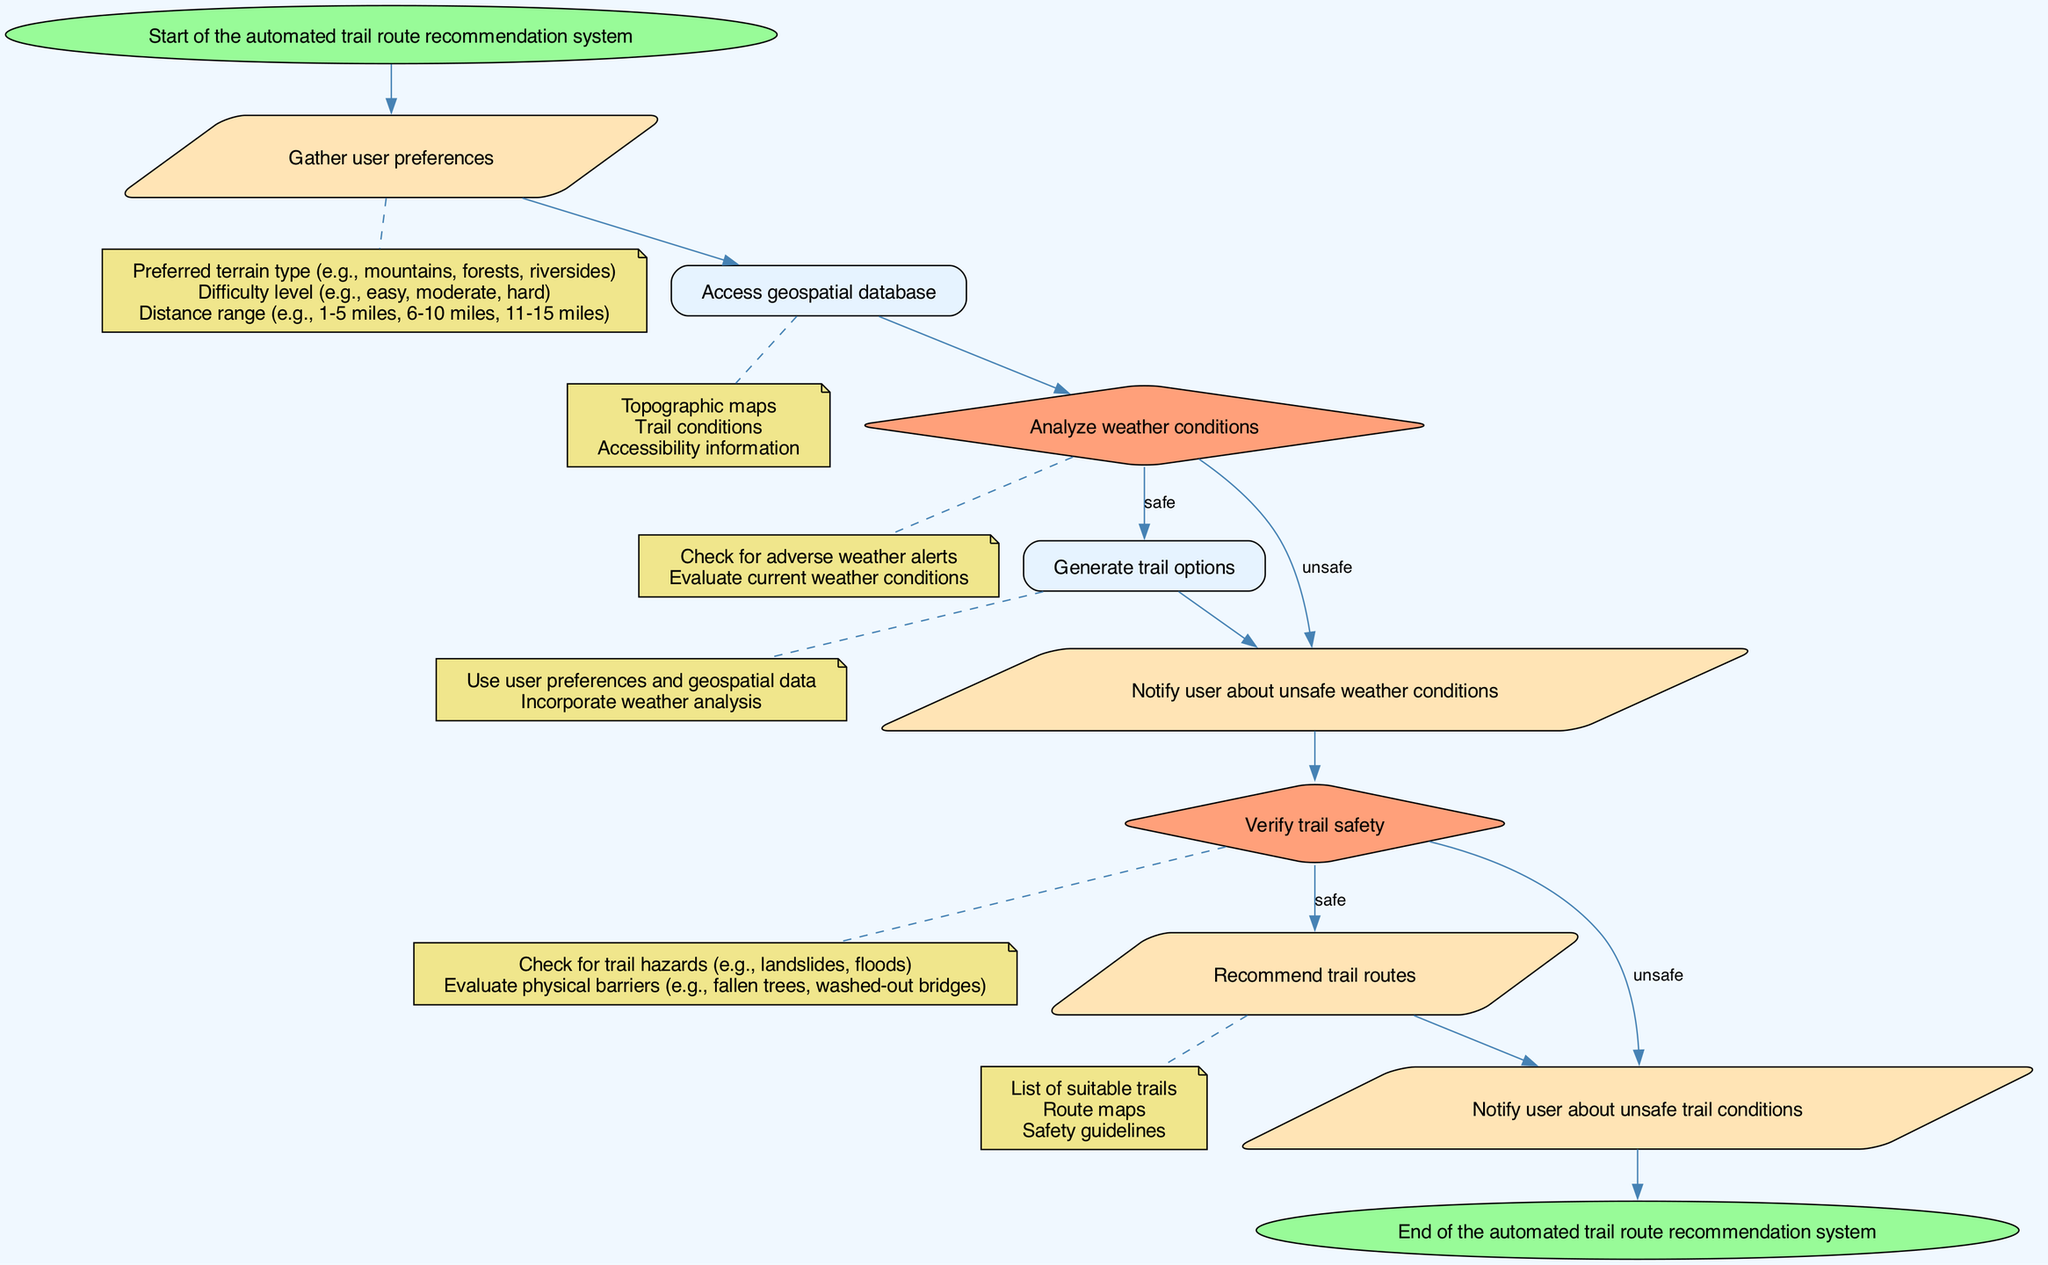What is the first node in the diagram? The diagram starts with the "Start" node, which marks the beginning of the automated trail route recommendation system. This is visually the first element in the flowchart labeled as "Start."
Answer: Start How many decision nodes are present in the diagram? The diagram contains two decision nodes: one to analyze weather conditions and the other to verify trail safety. These nodes are identified by their diamond shape in the flowchart.
Answer: 2 What type of information is gathered in the input node? The input node gathers user preferences, which include preferred terrain type, difficulty level, and distance range. This detail is presented under the input node in the flowchart.
Answer: User preferences What is the final output of the system if the trail is safe? When the trail is deemed safe, the system outputs a recommendation that includes a list of suitable trails, route maps, and safety guidelines, which follows the process of verifying trail safety.
Answer: Recommend trail routes What happens if the weather conditions are unsafe? If the weather conditions are unsafe, the system outputs a notification to the user about unsafe weather conditions. This clearly follows from the decision node evaluating weather safety in the flowchart.
Answer: Notify user about unsafe weather conditions How many edges connect the decision nodes to their respective outcomes? Each decision node has two edges connecting to their respective outcomes: one for a safe condition and one for an unsafe condition. Since there are two decision nodes, this results in a total of four edges.
Answer: 4 What is the last node in the flowchart? The last node in the flowchart is the "End" node, which signifies the completion of the automated trail route recommendation system. This is visually concluded in the flowchart.
Answer: End If a user prefers mountainous terrain and easy difficulty, which process follows after gathering preferences? After gathering the user preferences, the next process involves accessing the geospatial database, which is essential for generating relevant trail options based on the gathered data.
Answer: Access geospatial database What does the decision node evaluating trail safety check for? The decision node evaluating trail safety checks for trail hazards such as landslides and floods, as well as physical barriers like fallen trees. This detail is specified in the flowchart.
Answer: Trail hazards and physical barriers 